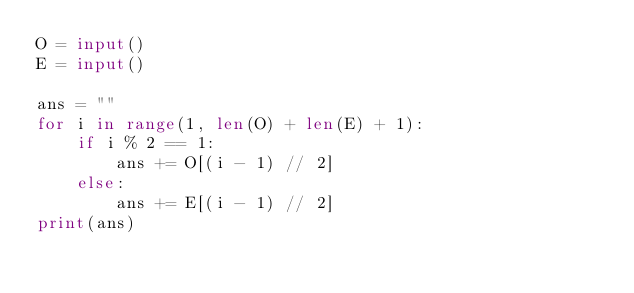<code> <loc_0><loc_0><loc_500><loc_500><_Python_>O = input()
E = input()

ans = ""
for i in range(1, len(O) + len(E) + 1):
    if i % 2 == 1:
        ans += O[(i - 1) // 2]
    else:
        ans += E[(i - 1) // 2]
print(ans)</code> 